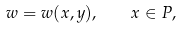Convert formula to latex. <formula><loc_0><loc_0><loc_500><loc_500>w = w ( x , y ) , \quad x \in P ,</formula> 